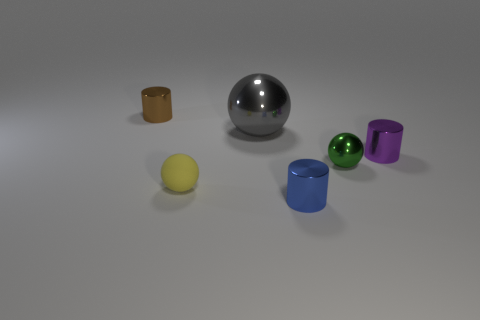Subtract all green balls. How many balls are left? 2 Add 1 rubber balls. How many objects exist? 7 Subtract all small purple rubber things. Subtract all gray shiny balls. How many objects are left? 5 Add 1 small green spheres. How many small green spheres are left? 2 Add 4 brown cylinders. How many brown cylinders exist? 5 Subtract all yellow balls. How many balls are left? 2 Subtract 0 yellow blocks. How many objects are left? 6 Subtract 2 spheres. How many spheres are left? 1 Subtract all blue cylinders. Subtract all green cubes. How many cylinders are left? 2 Subtract all red cylinders. How many yellow spheres are left? 1 